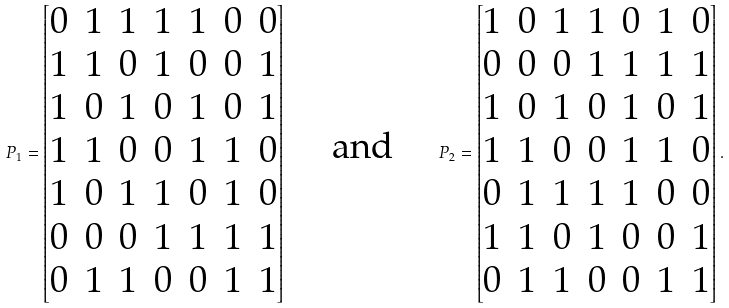Convert formula to latex. <formula><loc_0><loc_0><loc_500><loc_500>P _ { 1 } = \begin{bmatrix} 0 & 1 & 1 & 1 & 1 & 0 & 0 \\ 1 & 1 & 0 & 1 & 0 & 0 & 1 \\ 1 & 0 & 1 & 0 & 1 & 0 & 1 \\ 1 & 1 & 0 & 0 & 1 & 1 & 0 \\ 1 & 0 & 1 & 1 & 0 & 1 & 0 \\ 0 & 0 & 0 & 1 & 1 & 1 & 1 \\ 0 & 1 & 1 & 0 & 0 & 1 & 1 \end{bmatrix} \quad \text { and } \quad P _ { 2 } = \begin{bmatrix} 1 & 0 & 1 & 1 & 0 & 1 & 0 \\ 0 & 0 & 0 & 1 & 1 & 1 & 1 \\ 1 & 0 & 1 & 0 & 1 & 0 & 1 \\ 1 & 1 & 0 & 0 & 1 & 1 & 0 \\ 0 & 1 & 1 & 1 & 1 & 0 & 0 \\ 1 & 1 & 0 & 1 & 0 & 0 & 1 \\ 0 & 1 & 1 & 0 & 0 & 1 & 1 \end{bmatrix} .</formula> 